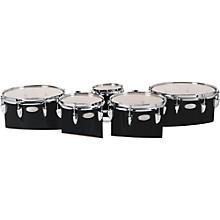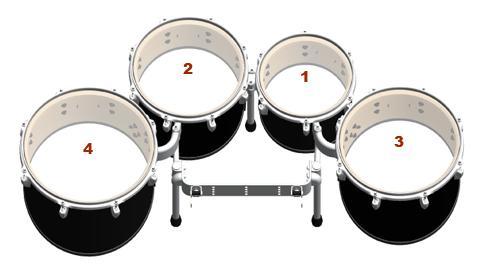The first image is the image on the left, the second image is the image on the right. For the images shown, is this caption "The drum base is white in the left image." true? Answer yes or no. No. The first image is the image on the left, the second image is the image on the right. Given the left and right images, does the statement "At least one kit contains more than four drums." hold true? Answer yes or no. Yes. 